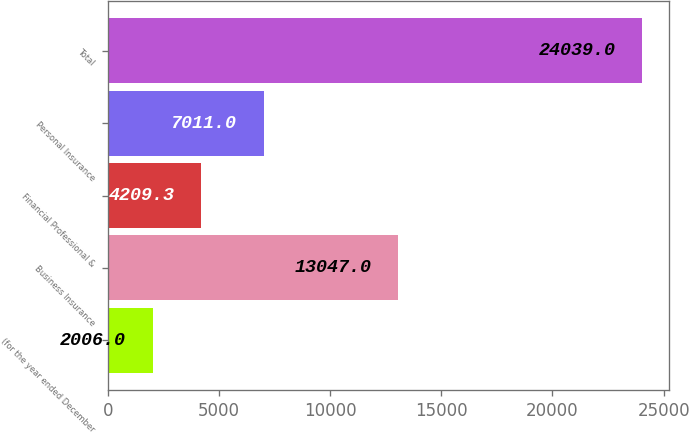Convert chart to OTSL. <chart><loc_0><loc_0><loc_500><loc_500><bar_chart><fcel>(for the year ended December<fcel>Business Insurance<fcel>Financial Professional &<fcel>Personal Insurance<fcel>Total<nl><fcel>2006<fcel>13047<fcel>4209.3<fcel>7011<fcel>24039<nl></chart> 